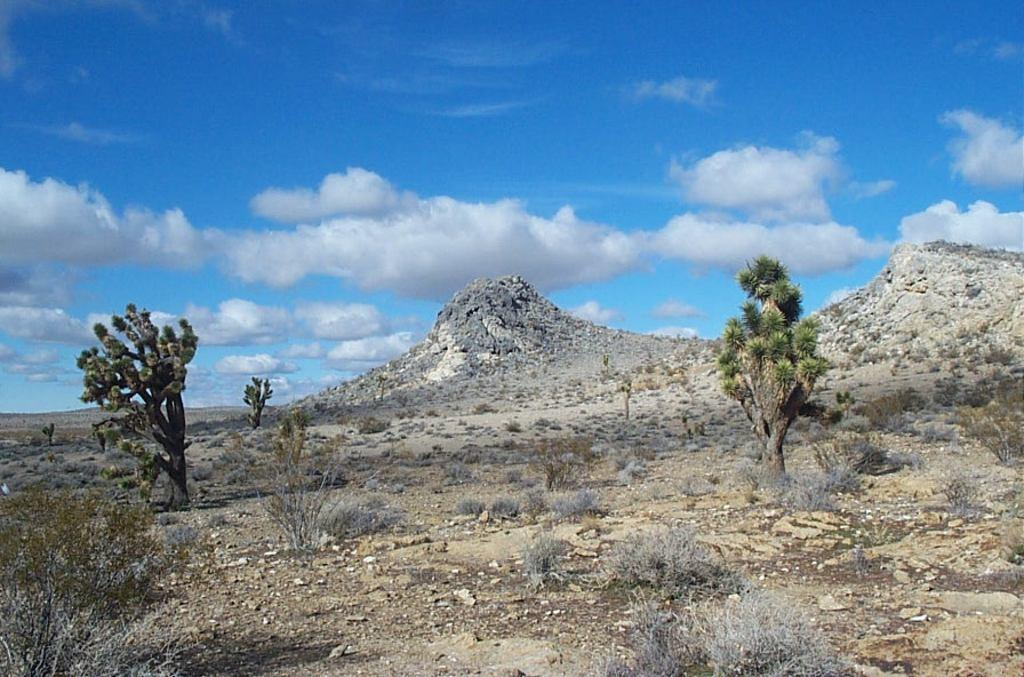What can be seen in the sky in the image? The sky with clouds is visible in the image. What type of natural features are present in the image? There are hills, trees, plants, rocks, and shrubs visible in the image. Can you tell me who won the fight between the vase and the arithmetic in the image? There is no fight between a vase and arithmetic present in the image, as these objects are not mentioned in the provided facts. 